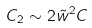<formula> <loc_0><loc_0><loc_500><loc_500>C _ { 2 } \sim 2 \tilde { w } ^ { 2 } C</formula> 